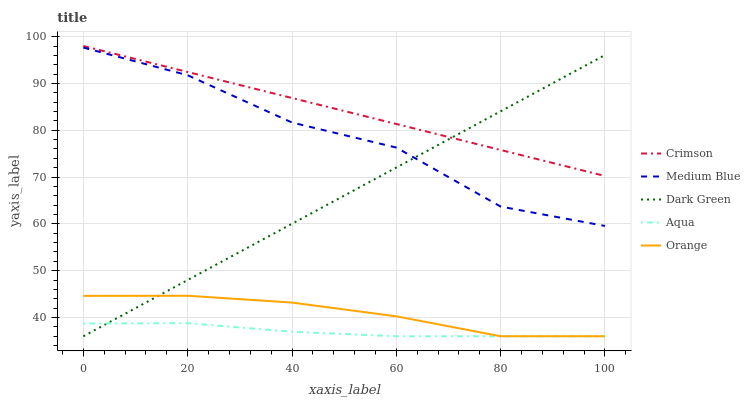Does Aqua have the minimum area under the curve?
Answer yes or no. Yes. Does Crimson have the maximum area under the curve?
Answer yes or no. Yes. Does Orange have the minimum area under the curve?
Answer yes or no. No. Does Orange have the maximum area under the curve?
Answer yes or no. No. Is Crimson the smoothest?
Answer yes or no. Yes. Is Medium Blue the roughest?
Answer yes or no. Yes. Is Aqua the smoothest?
Answer yes or no. No. Is Aqua the roughest?
Answer yes or no. No. Does Aqua have the lowest value?
Answer yes or no. Yes. Does Medium Blue have the lowest value?
Answer yes or no. No. Does Crimson have the highest value?
Answer yes or no. Yes. Does Orange have the highest value?
Answer yes or no. No. Is Orange less than Medium Blue?
Answer yes or no. Yes. Is Medium Blue greater than Aqua?
Answer yes or no. Yes. Does Aqua intersect Orange?
Answer yes or no. Yes. Is Aqua less than Orange?
Answer yes or no. No. Is Aqua greater than Orange?
Answer yes or no. No. Does Orange intersect Medium Blue?
Answer yes or no. No. 